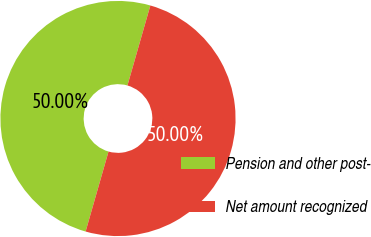Convert chart to OTSL. <chart><loc_0><loc_0><loc_500><loc_500><pie_chart><fcel>Pension and other post-<fcel>Net amount recognized<nl><fcel>50.0%<fcel>50.0%<nl></chart> 